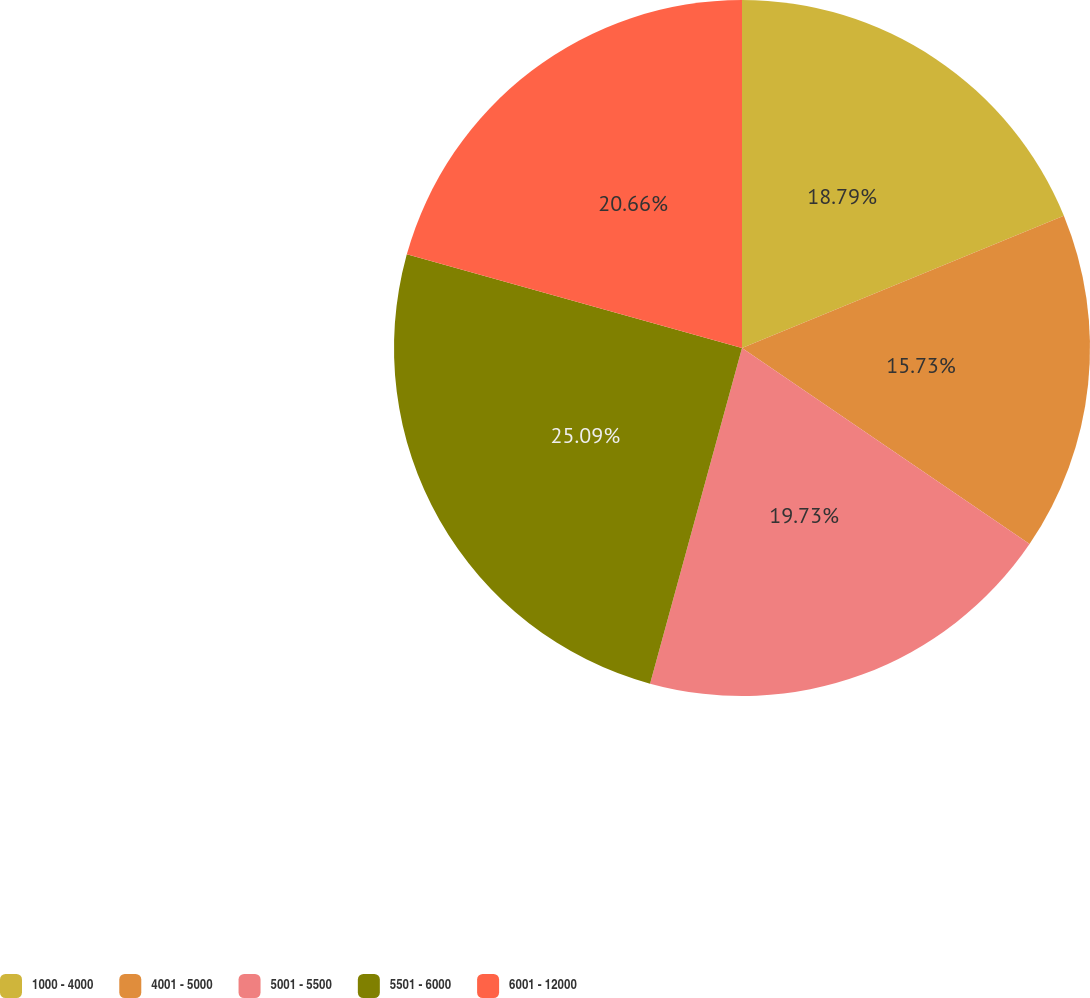Convert chart to OTSL. <chart><loc_0><loc_0><loc_500><loc_500><pie_chart><fcel>1000 - 4000<fcel>4001 - 5000<fcel>5001 - 5500<fcel>5501 - 6000<fcel>6001 - 12000<nl><fcel>18.79%<fcel>15.73%<fcel>19.73%<fcel>25.08%<fcel>20.66%<nl></chart> 